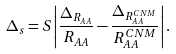Convert formula to latex. <formula><loc_0><loc_0><loc_500><loc_500>\Delta _ { s } = S \left | \frac { \Delta _ { R _ { A A } } } { R _ { A A } } - \frac { \Delta _ { R _ { A A } ^ { C N M } } } { R _ { A A } ^ { C N M } } \right | .</formula> 